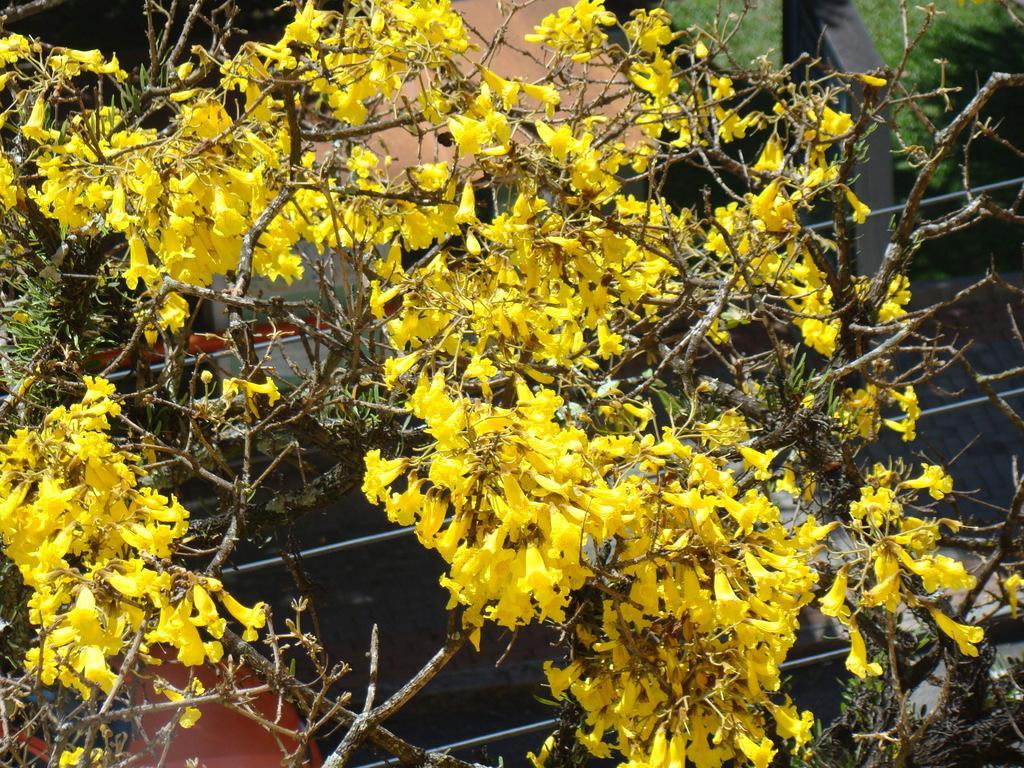Could you give a brief overview of what you see in this image? In this image, we can see plants with flowers and in the background, there are some objects. 